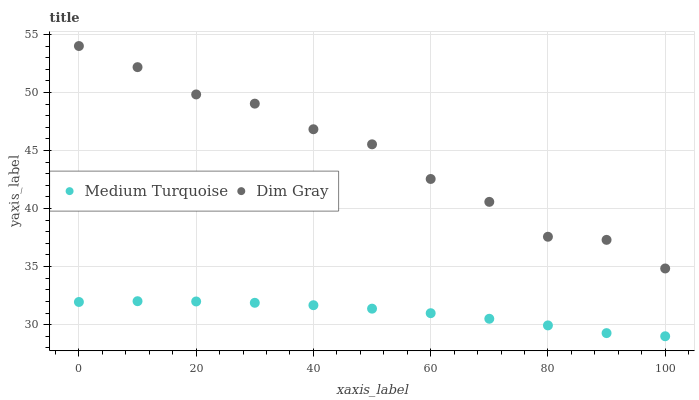Does Medium Turquoise have the minimum area under the curve?
Answer yes or no. Yes. Does Dim Gray have the maximum area under the curve?
Answer yes or no. Yes. Does Medium Turquoise have the maximum area under the curve?
Answer yes or no. No. Is Medium Turquoise the smoothest?
Answer yes or no. Yes. Is Dim Gray the roughest?
Answer yes or no. Yes. Is Medium Turquoise the roughest?
Answer yes or no. No. Does Medium Turquoise have the lowest value?
Answer yes or no. Yes. Does Dim Gray have the highest value?
Answer yes or no. Yes. Does Medium Turquoise have the highest value?
Answer yes or no. No. Is Medium Turquoise less than Dim Gray?
Answer yes or no. Yes. Is Dim Gray greater than Medium Turquoise?
Answer yes or no. Yes. Does Medium Turquoise intersect Dim Gray?
Answer yes or no. No. 